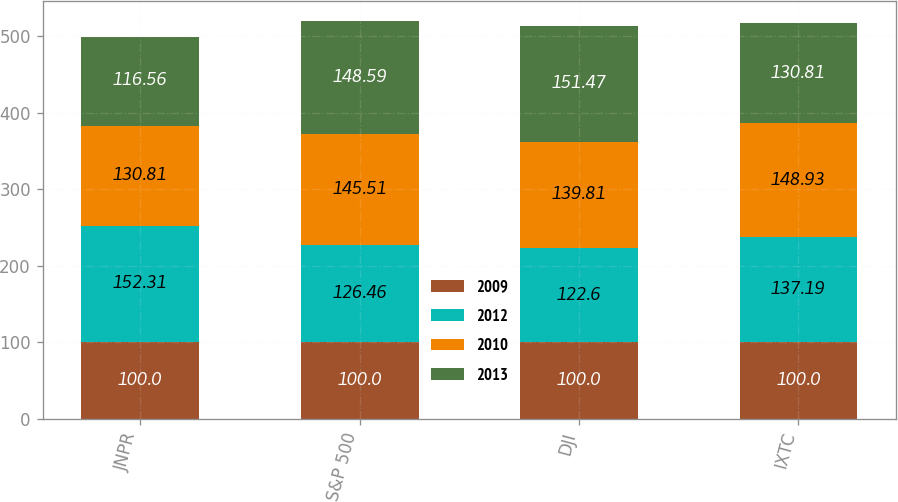Convert chart. <chart><loc_0><loc_0><loc_500><loc_500><stacked_bar_chart><ecel><fcel>JNPR<fcel>S&P 500<fcel>DJI<fcel>IXTC<nl><fcel>2009<fcel>100<fcel>100<fcel>100<fcel>100<nl><fcel>2012<fcel>152.31<fcel>126.46<fcel>122.6<fcel>137.19<nl><fcel>2010<fcel>130.81<fcel>145.51<fcel>139.81<fcel>148.93<nl><fcel>2013<fcel>116.56<fcel>148.59<fcel>151.47<fcel>130.81<nl></chart> 